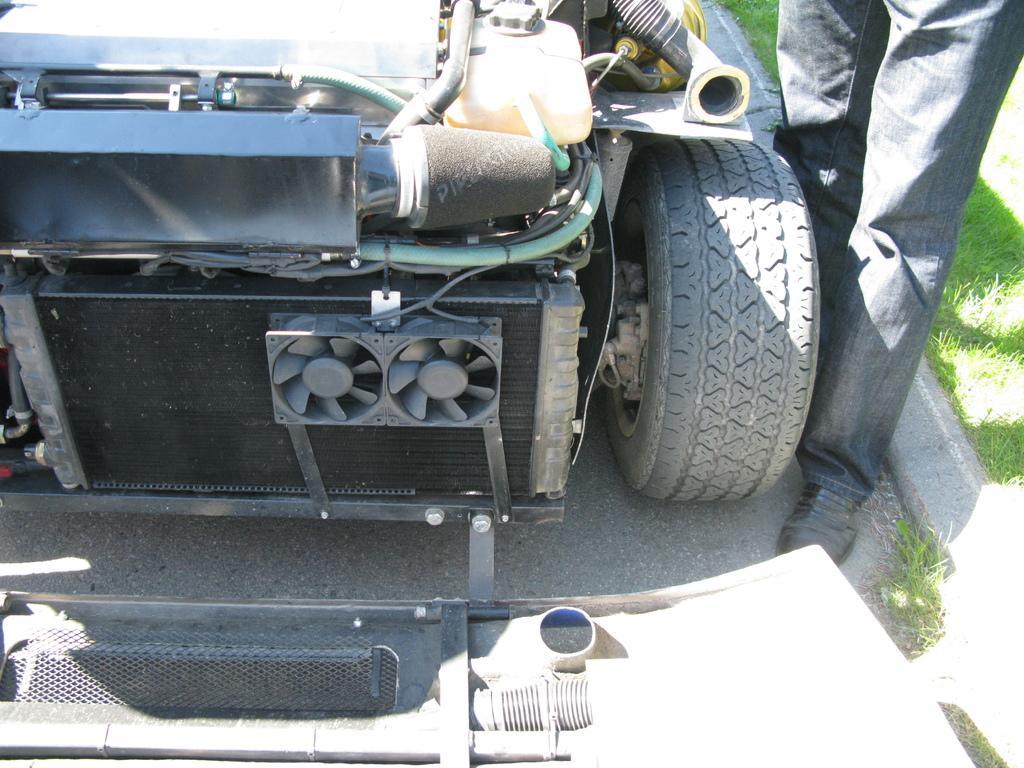Describe this image in one or two sentences. In this image we can see a vehicle, person's legs, grass on the ground and a metal object on the road. 